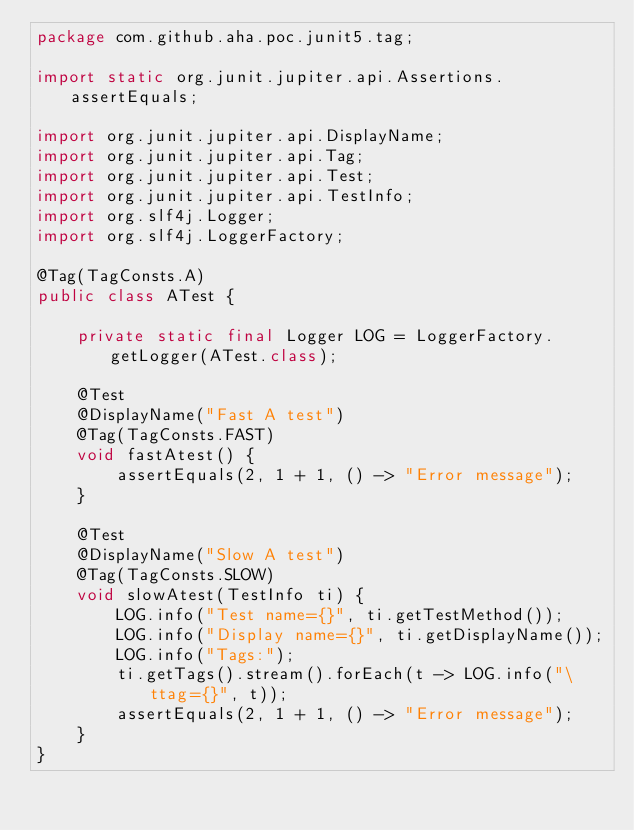Convert code to text. <code><loc_0><loc_0><loc_500><loc_500><_Java_>package com.github.aha.poc.junit5.tag;

import static org.junit.jupiter.api.Assertions.assertEquals;

import org.junit.jupiter.api.DisplayName;
import org.junit.jupiter.api.Tag;
import org.junit.jupiter.api.Test;
import org.junit.jupiter.api.TestInfo;
import org.slf4j.Logger;
import org.slf4j.LoggerFactory;

@Tag(TagConsts.A)
public class ATest {

	private static final Logger LOG = LoggerFactory.getLogger(ATest.class);
	
	@Test
	@DisplayName("Fast A test")
	@Tag(TagConsts.FAST)
	void fastAtest() {
		assertEquals(2, 1 + 1, () -> "Error message");
	}
	
	@Test
	@DisplayName("Slow A test")
	@Tag(TagConsts.SLOW)
	void slowAtest(TestInfo ti) {
		LOG.info("Test name={}", ti.getTestMethod());
		LOG.info("Display name={}", ti.getDisplayName());
		LOG.info("Tags:");
		ti.getTags().stream().forEach(t -> LOG.info("\ttag={}", t));
		assertEquals(2, 1 + 1, () -> "Error message");
	}
}
</code> 